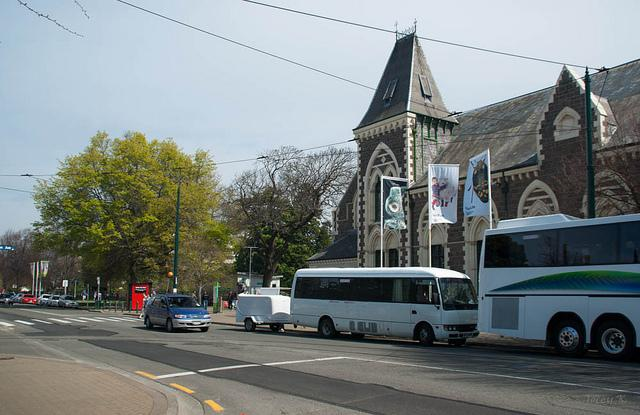What are these banners promoting? Please explain your reasoning. museums. The banners promote museums. 